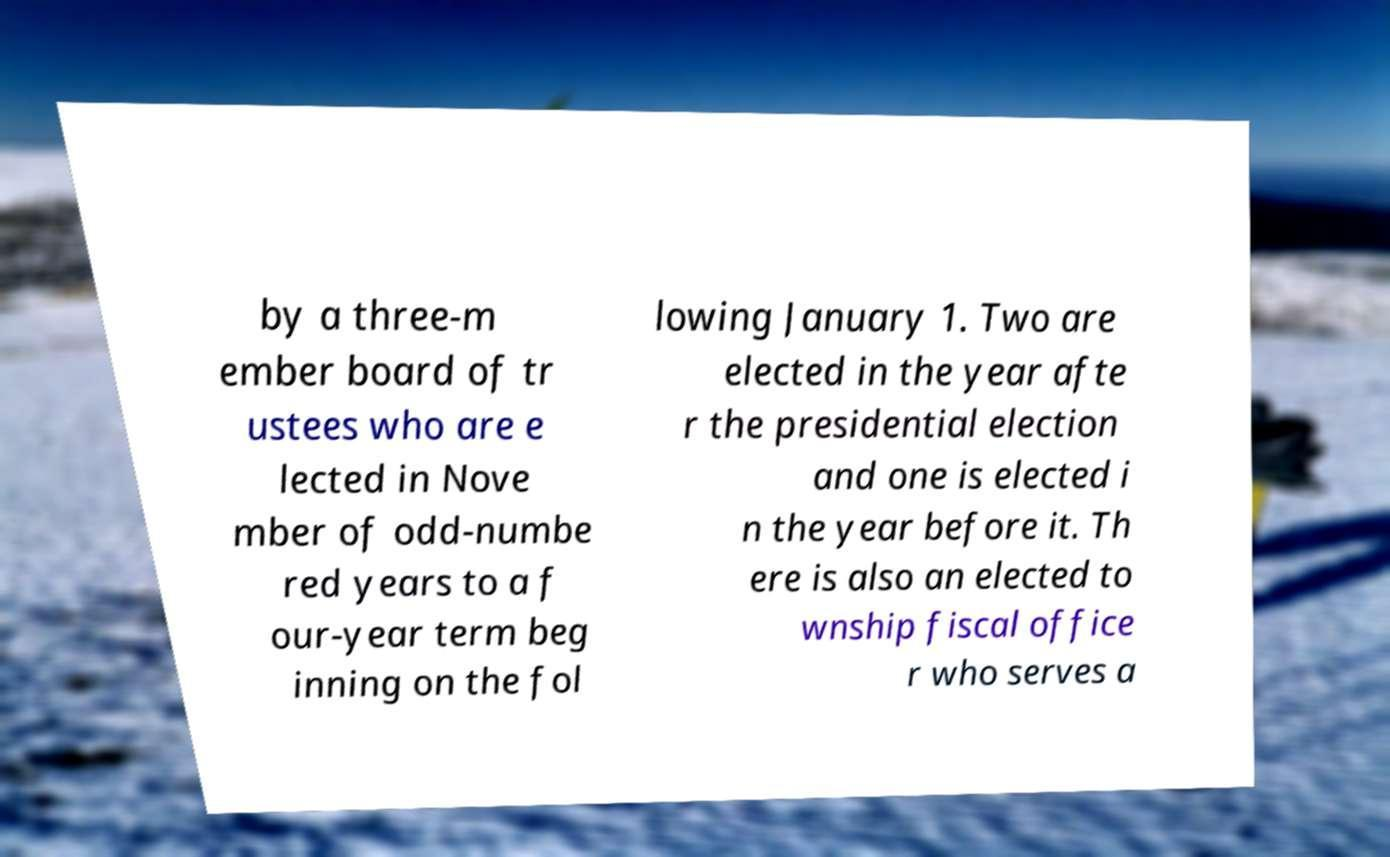Please read and relay the text visible in this image. What does it say? by a three-m ember board of tr ustees who are e lected in Nove mber of odd-numbe red years to a f our-year term beg inning on the fol lowing January 1. Two are elected in the year afte r the presidential election and one is elected i n the year before it. Th ere is also an elected to wnship fiscal office r who serves a 